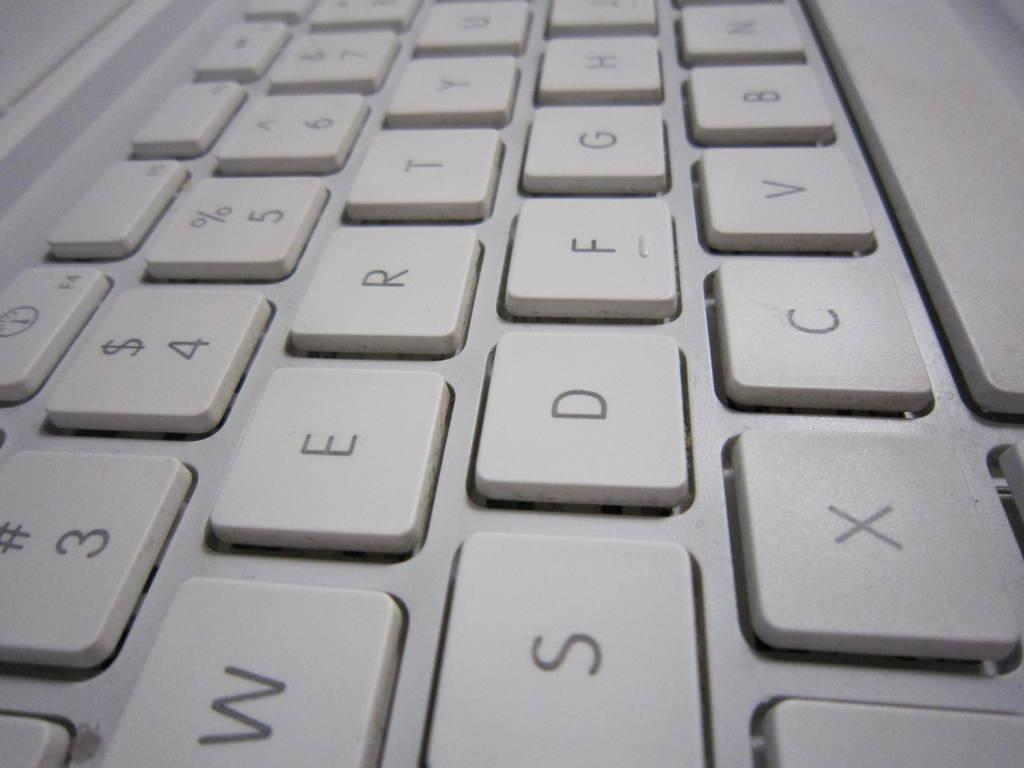<image>
Summarize the visual content of the image. A plain white keyboard with white keys on the second row from the bottom which are S,D,F, and G. 